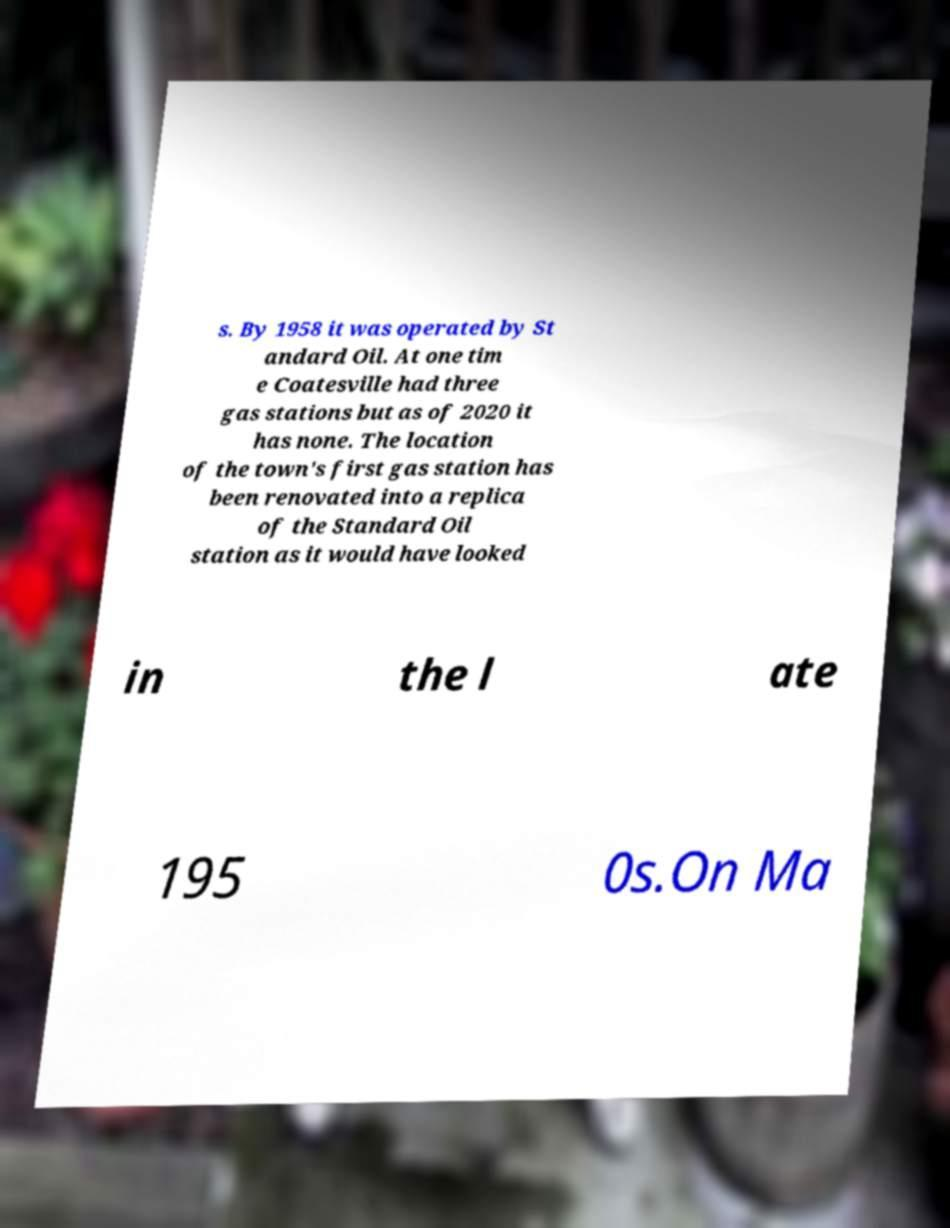There's text embedded in this image that I need extracted. Can you transcribe it verbatim? s. By 1958 it was operated by St andard Oil. At one tim e Coatesville had three gas stations but as of 2020 it has none. The location of the town's first gas station has been renovated into a replica of the Standard Oil station as it would have looked in the l ate 195 0s.On Ma 